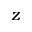<formula> <loc_0><loc_0><loc_500><loc_500>z</formula> 